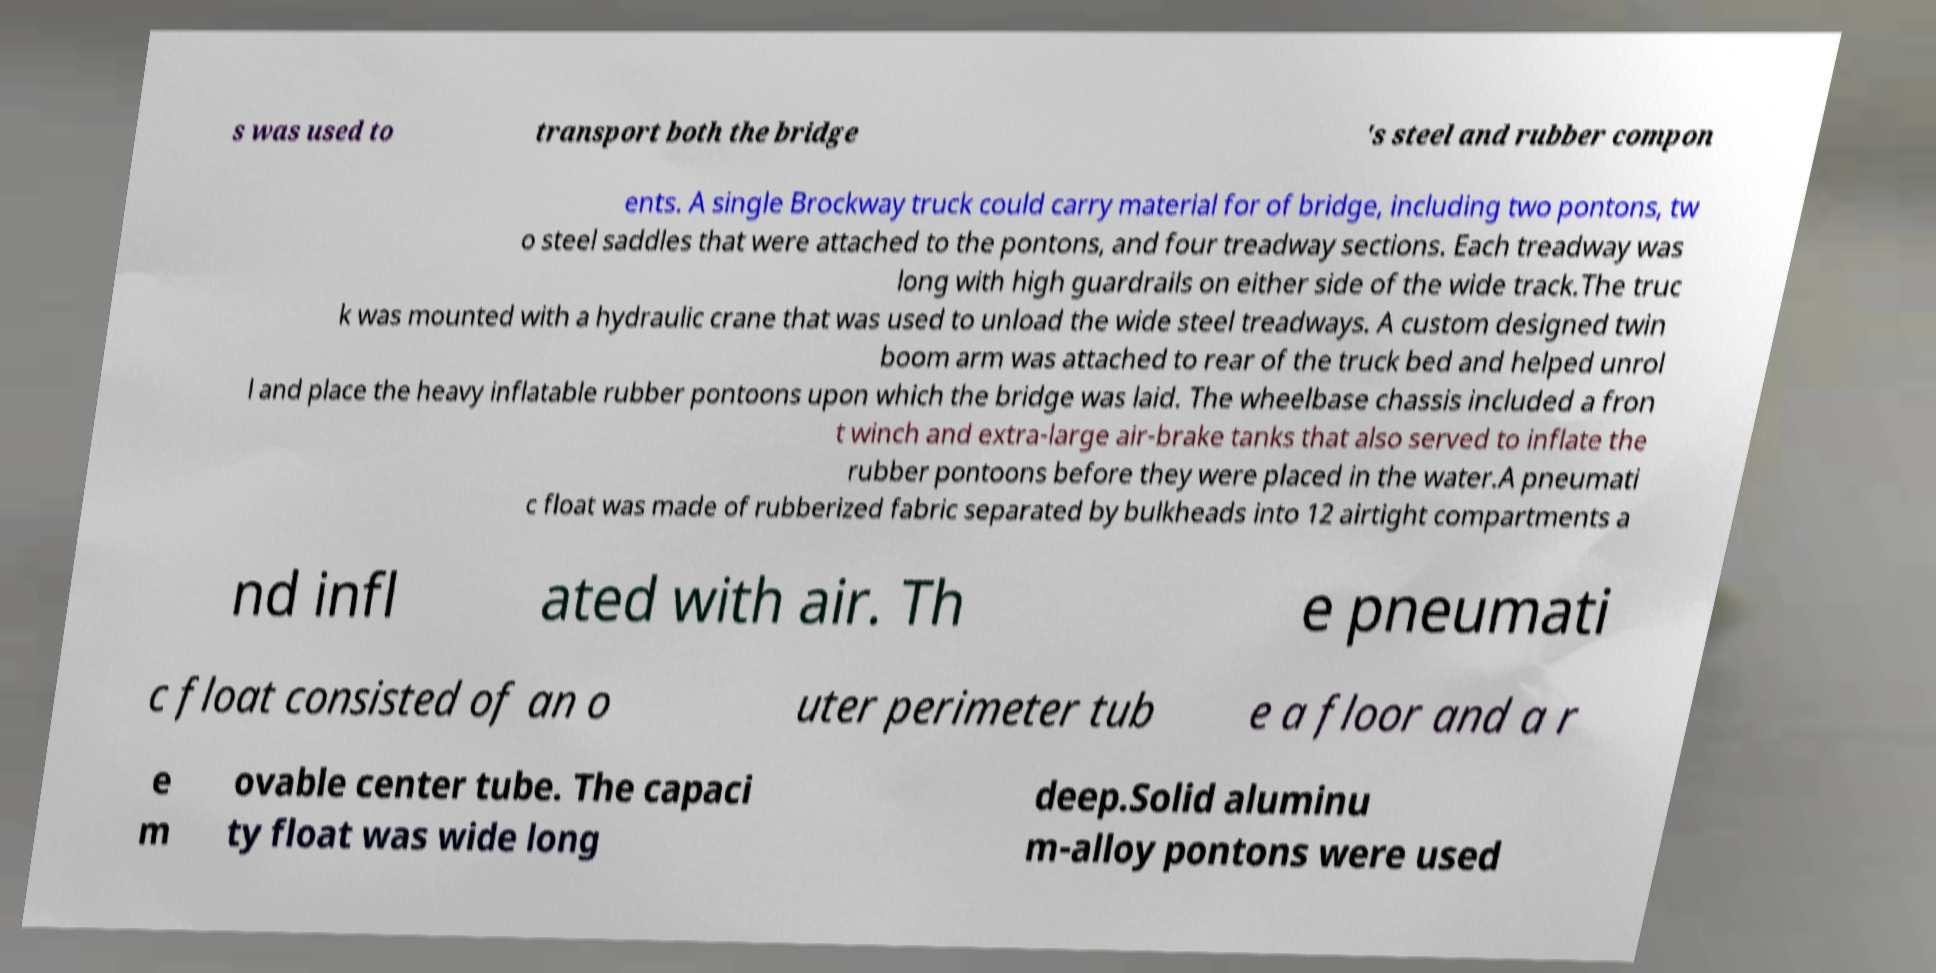Can you accurately transcribe the text from the provided image for me? s was used to transport both the bridge 's steel and rubber compon ents. A single Brockway truck could carry material for of bridge, including two pontons, tw o steel saddles that were attached to the pontons, and four treadway sections. Each treadway was long with high guardrails on either side of the wide track.The truc k was mounted with a hydraulic crane that was used to unload the wide steel treadways. A custom designed twin boom arm was attached to rear of the truck bed and helped unrol l and place the heavy inflatable rubber pontoons upon which the bridge was laid. The wheelbase chassis included a fron t winch and extra-large air-brake tanks that also served to inflate the rubber pontoons before they were placed in the water.A pneumati c float was made of rubberized fabric separated by bulkheads into 12 airtight compartments a nd infl ated with air. Th e pneumati c float consisted of an o uter perimeter tub e a floor and a r e m ovable center tube. The capaci ty float was wide long deep.Solid aluminu m-alloy pontons were used 